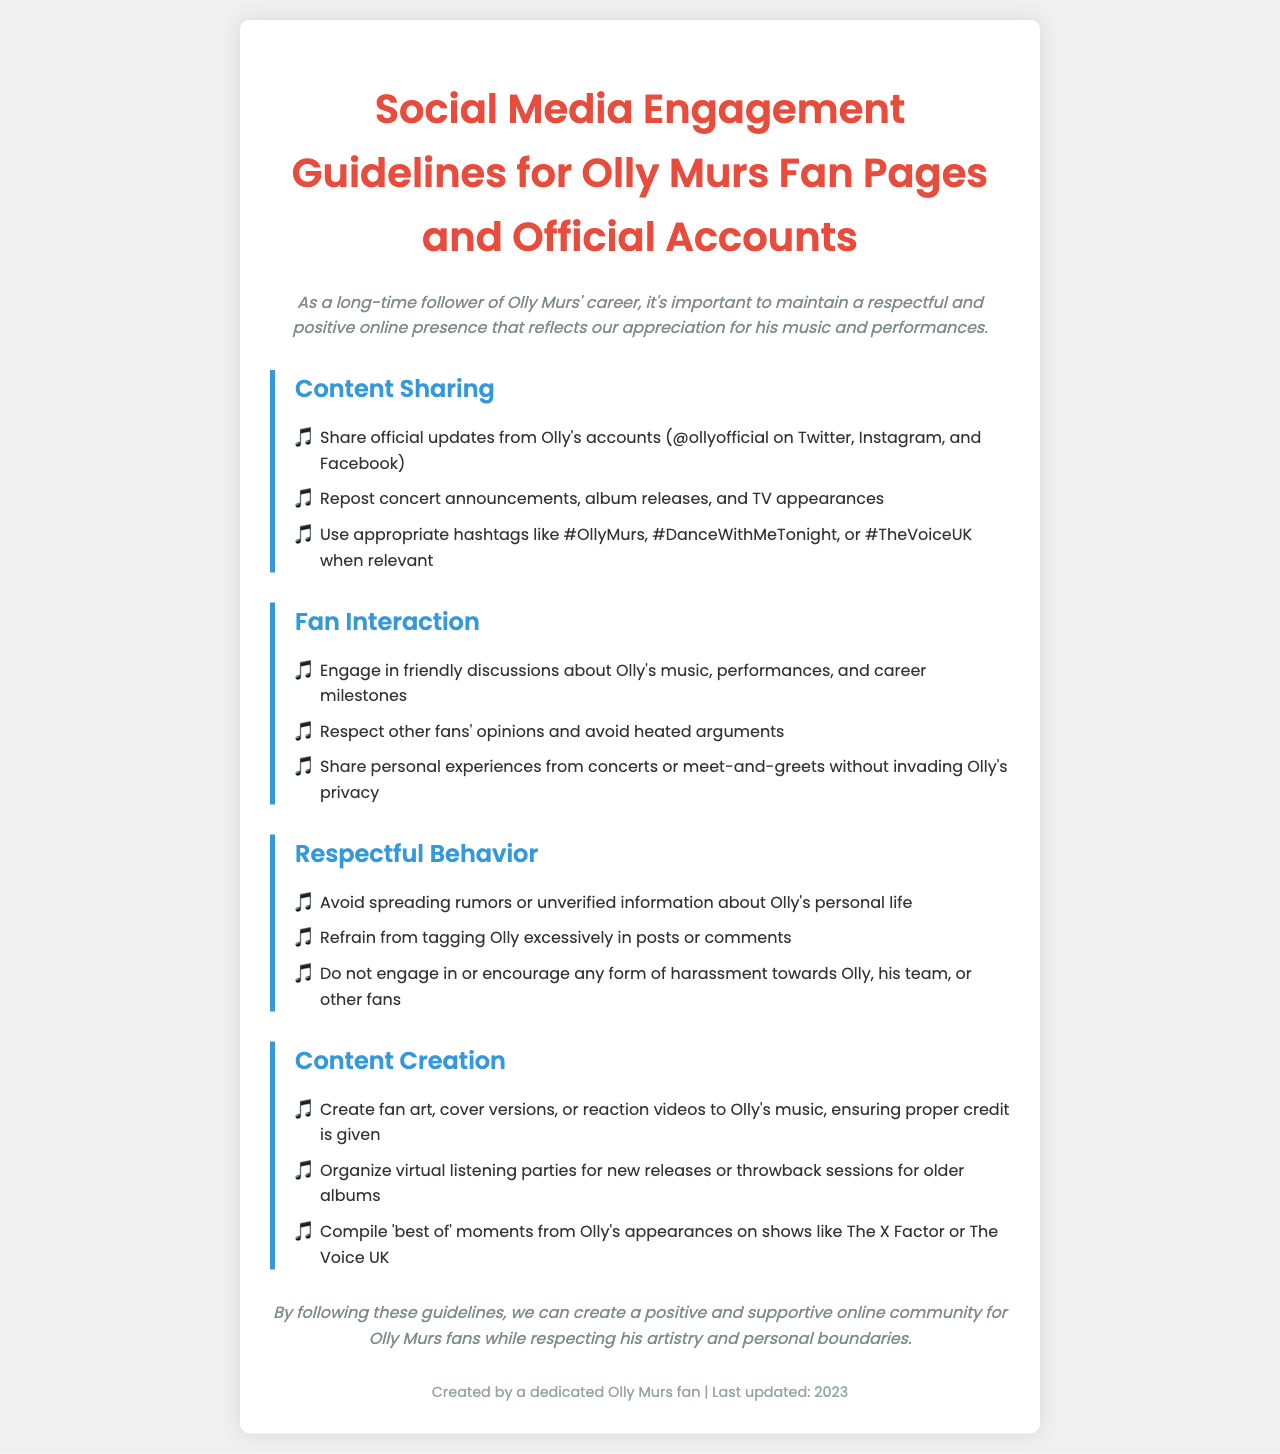What is the title of the document? The title is clearly stated at the top of the document.
Answer: Social Media Engagement Guidelines for Olly Murs Fan Pages and Official Accounts How many sections are in the document? The document lists four main sections regarding guidelines.
Answer: Four What is the first guideline under Content Sharing? The first guideline is specifically mentioned in the list of content sharing practices.
Answer: Share official updates from Olly's accounts What should fans avoid regarding Olly's personal life? The document specifies certain behaviors to maintain respect.
Answer: Spreading rumors or unverified information What is suggested for fan interaction? The document encourages certain behaviors when interacting with other fans.
Answer: Engage in friendly discussions What type of content can fans create? The document provides examples of appropriate content creation.
Answer: Fan art, cover versions, or reaction videos What is the purpose of the guidelines? The introduction outlines the overall intent of the guidelines.
Answer: Create a positive and supportive online community What is the color of the heading in the sections? The document indicates the styling choices made for the section headings.
Answer: Blue What is indicated as excessive behavior towards Olly? The document mentions specific actions to avoid when interacting with Olly.
Answer: Tagging Olly excessively 